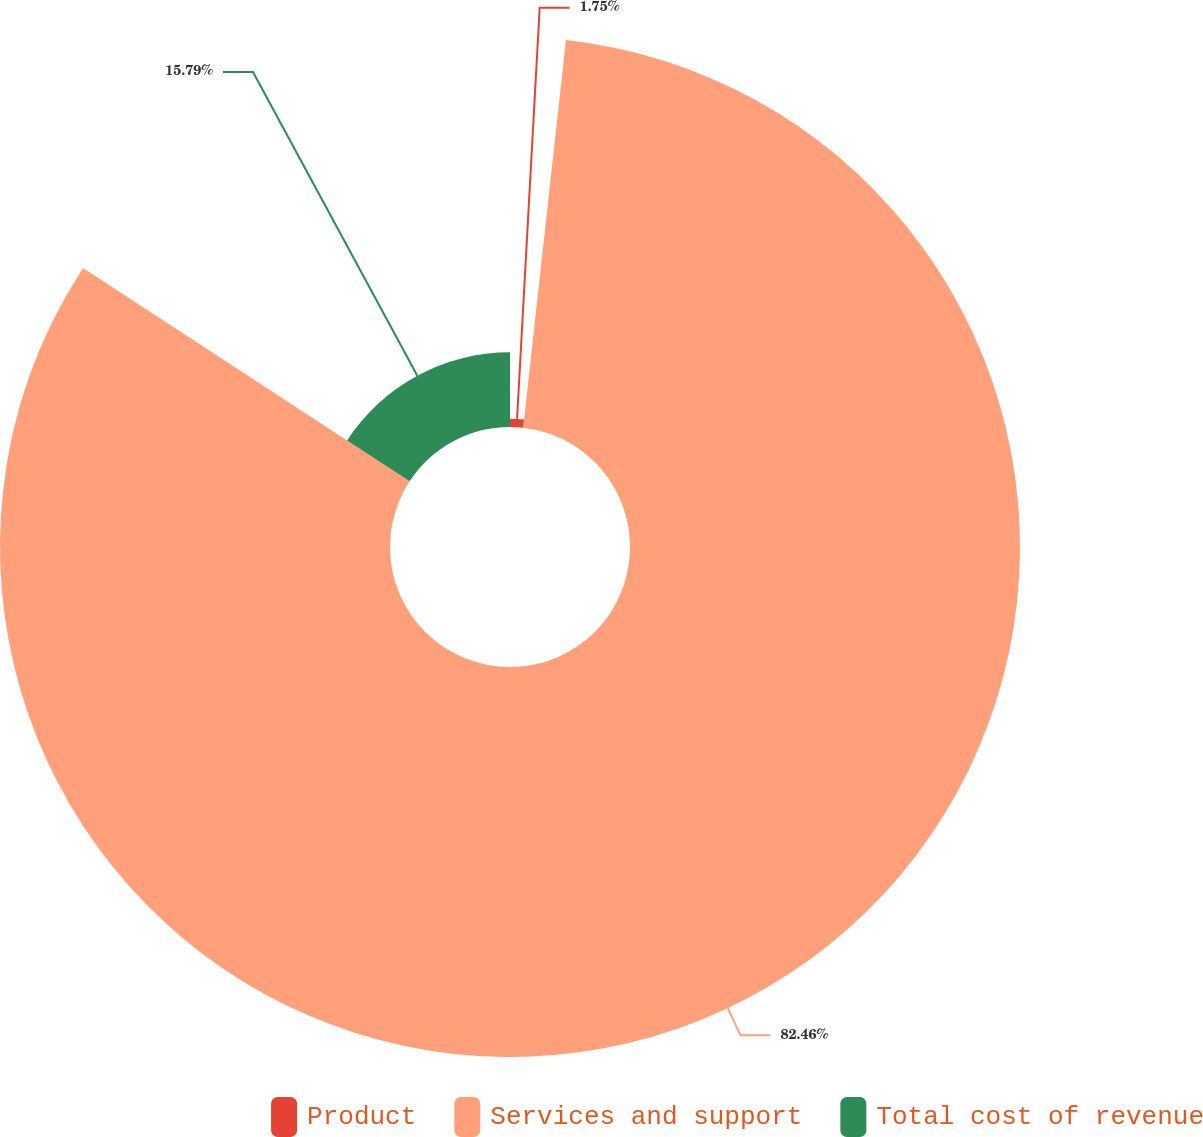<chart> <loc_0><loc_0><loc_500><loc_500><pie_chart><fcel>Product<fcel>Services and support<fcel>Total cost of revenue<nl><fcel>1.75%<fcel>82.46%<fcel>15.79%<nl></chart> 